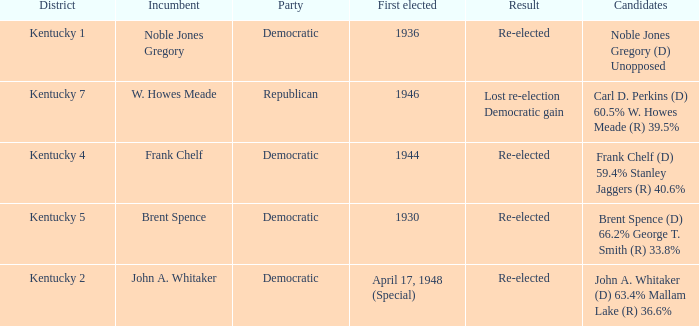Who were the candidates in the Kentucky 4 voting district? Frank Chelf (D) 59.4% Stanley Jaggers (R) 40.6%. 